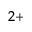Convert formula to latex. <formula><loc_0><loc_0><loc_500><loc_500>^ { 2 + }</formula> 